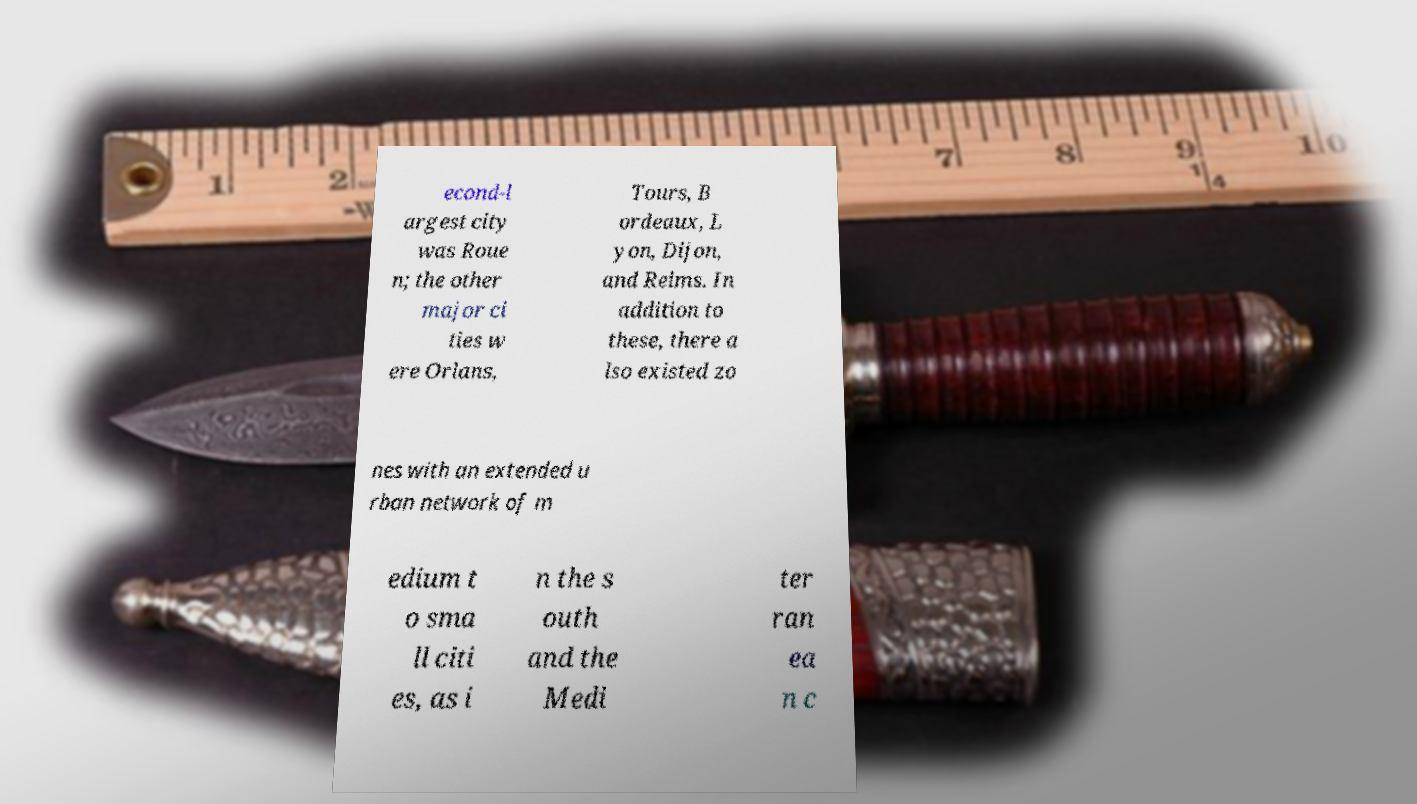Could you assist in decoding the text presented in this image and type it out clearly? econd-l argest city was Roue n; the other major ci ties w ere Orlans, Tours, B ordeaux, L yon, Dijon, and Reims. In addition to these, there a lso existed zo nes with an extended u rban network of m edium t o sma ll citi es, as i n the s outh and the Medi ter ran ea n c 